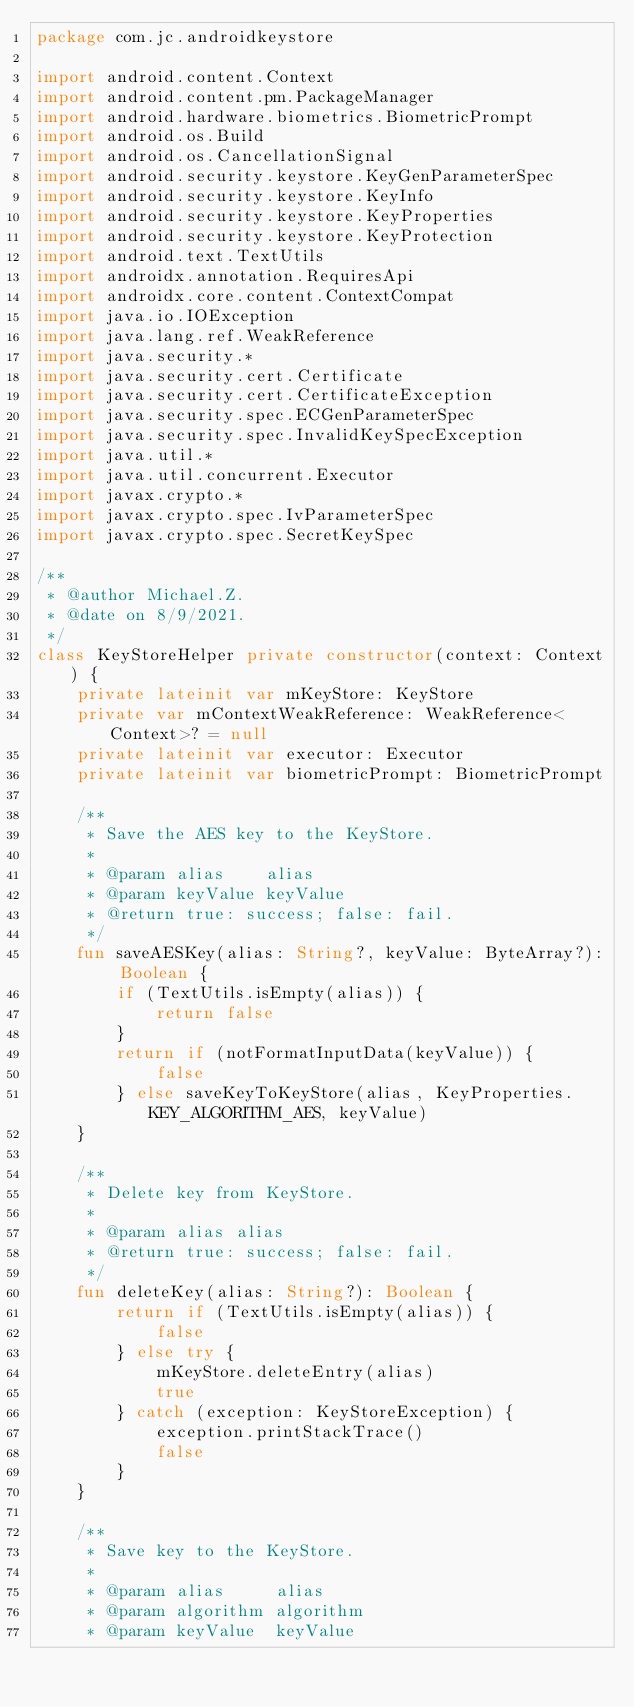<code> <loc_0><loc_0><loc_500><loc_500><_Kotlin_>package com.jc.androidkeystore

import android.content.Context
import android.content.pm.PackageManager
import android.hardware.biometrics.BiometricPrompt
import android.os.Build
import android.os.CancellationSignal
import android.security.keystore.KeyGenParameterSpec
import android.security.keystore.KeyInfo
import android.security.keystore.KeyProperties
import android.security.keystore.KeyProtection
import android.text.TextUtils
import androidx.annotation.RequiresApi
import androidx.core.content.ContextCompat
import java.io.IOException
import java.lang.ref.WeakReference
import java.security.*
import java.security.cert.Certificate
import java.security.cert.CertificateException
import java.security.spec.ECGenParameterSpec
import java.security.spec.InvalidKeySpecException
import java.util.*
import java.util.concurrent.Executor
import javax.crypto.*
import javax.crypto.spec.IvParameterSpec
import javax.crypto.spec.SecretKeySpec

/**
 * @author Michael.Z.
 * @date on 8/9/2021.
 */
class KeyStoreHelper private constructor(context: Context) {
    private lateinit var mKeyStore: KeyStore
    private var mContextWeakReference: WeakReference<Context>? = null
    private lateinit var executor: Executor
    private lateinit var biometricPrompt: BiometricPrompt

    /**
     * Save the AES key to the KeyStore.
     *
     * @param alias    alias
     * @param keyValue keyValue
     * @return true: success; false: fail.
     */
    fun saveAESKey(alias: String?, keyValue: ByteArray?): Boolean {
        if (TextUtils.isEmpty(alias)) {
            return false
        }
        return if (notFormatInputData(keyValue)) {
            false
        } else saveKeyToKeyStore(alias, KeyProperties.KEY_ALGORITHM_AES, keyValue)
    }

    /**
     * Delete key from KeyStore.
     *
     * @param alias alias
     * @return true: success; false: fail.
     */
    fun deleteKey(alias: String?): Boolean {
        return if (TextUtils.isEmpty(alias)) {
            false
        } else try {
            mKeyStore.deleteEntry(alias)
            true
        } catch (exception: KeyStoreException) {
            exception.printStackTrace()
            false
        }
    }

    /**
     * Save key to the KeyStore.
     *
     * @param alias     alias
     * @param algorithm algorithm
     * @param keyValue  keyValue</code> 